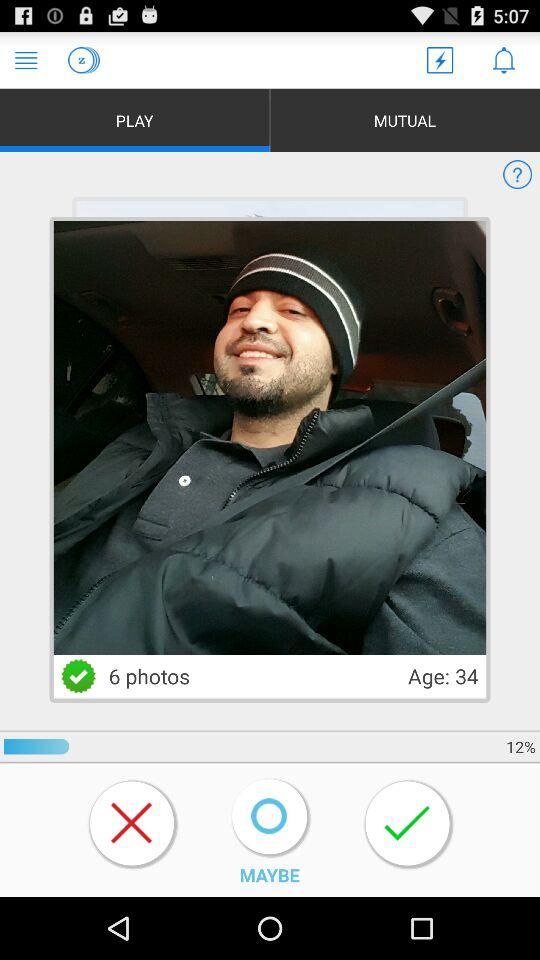Which tab is open? The open tab is "PLAY". 